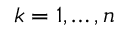Convert formula to latex. <formula><loc_0><loc_0><loc_500><loc_500>k = 1 , \dots , n</formula> 